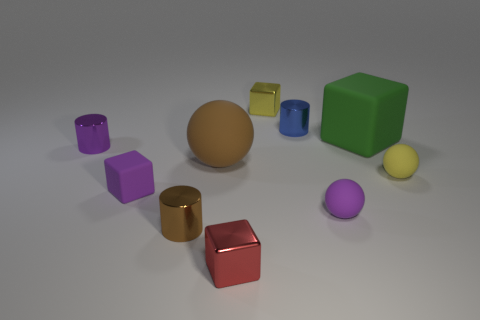Which objects in the image have a reflective surface? The objects with reflective surfaces include the small brown metallic cylinder, the red cube, and the golden cylinder. Their shiny textures catch the light, suggesting a metal-like material. 